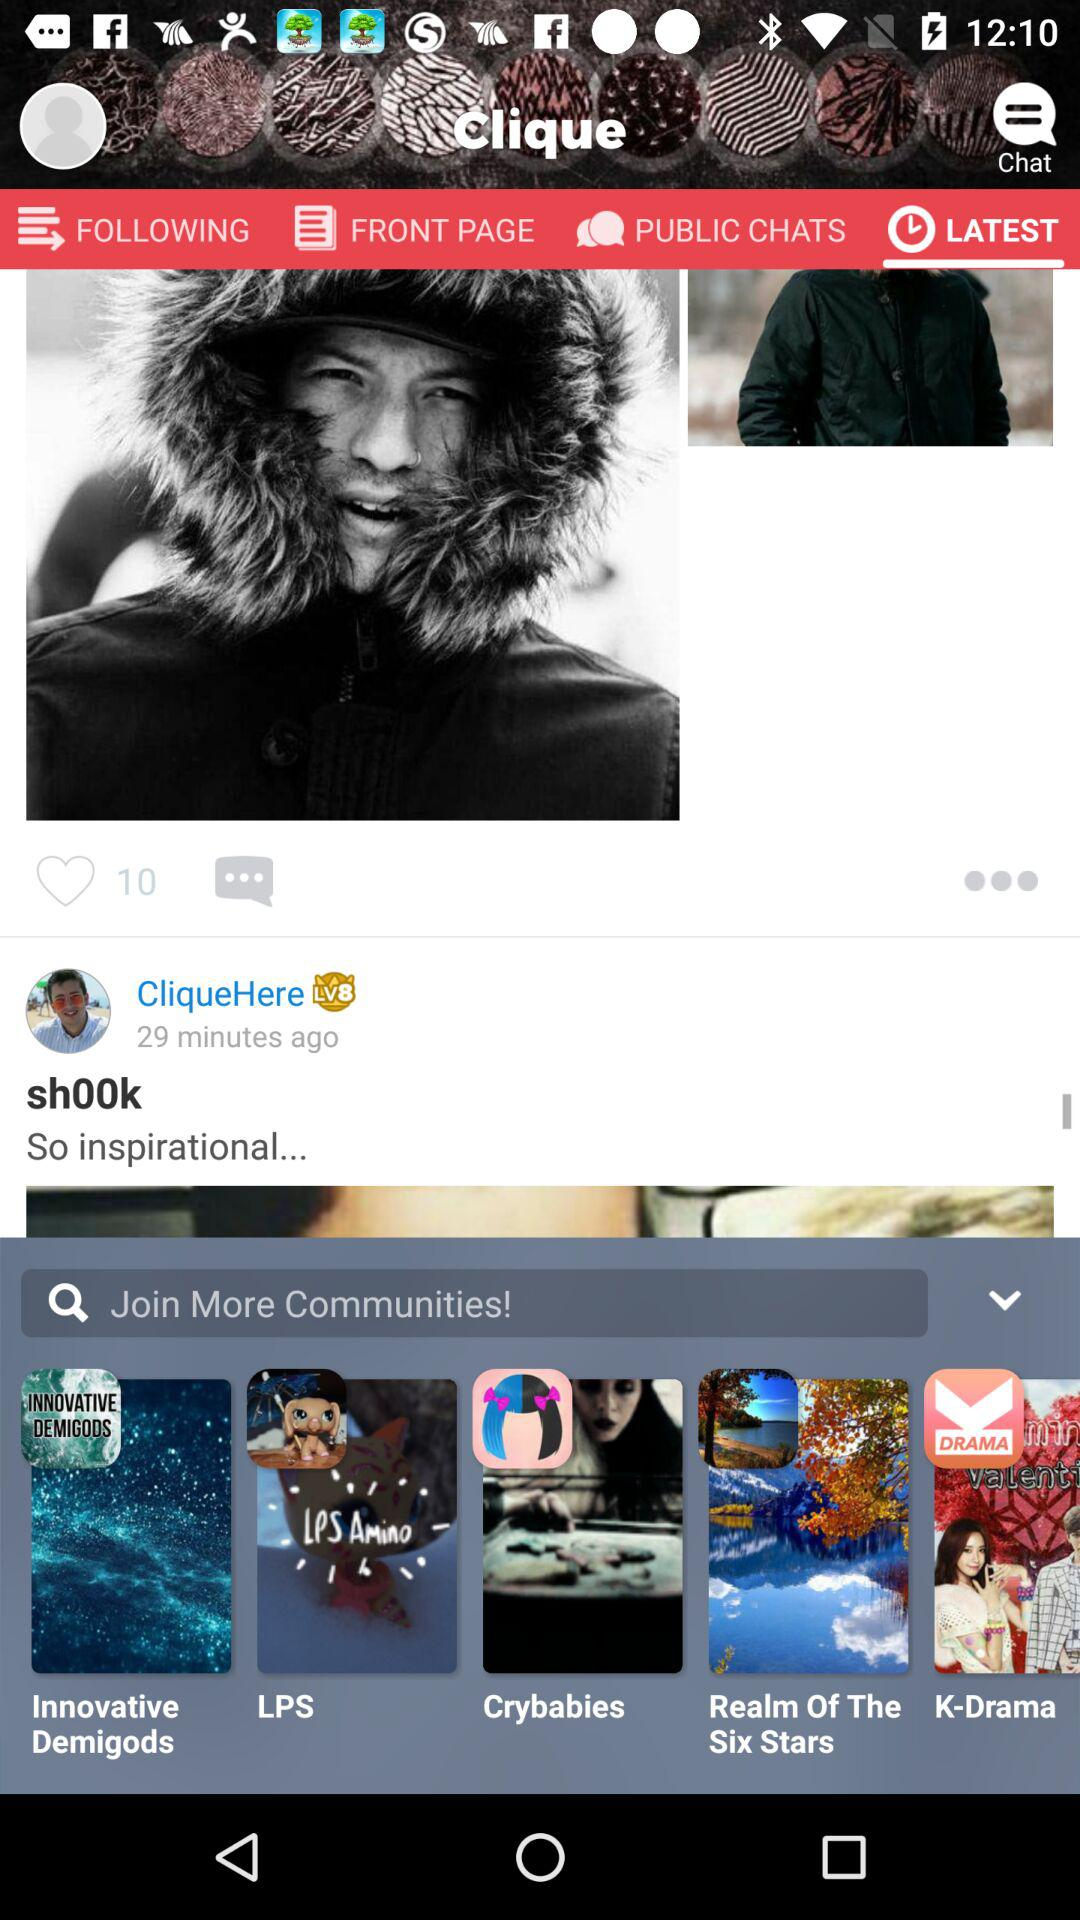How many minutes ago was the post from "CliqueHere" posted? The post from "CliqueHere" was posted 29 minutes ago. 